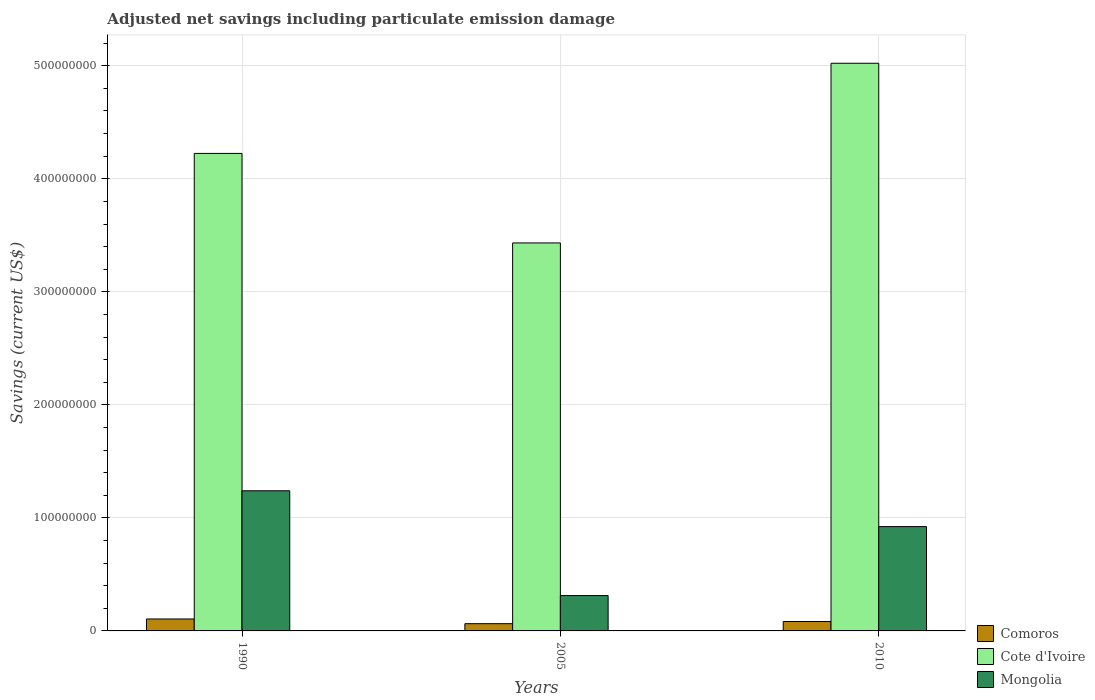How many different coloured bars are there?
Offer a very short reply. 3. How many groups of bars are there?
Offer a terse response. 3. Are the number of bars per tick equal to the number of legend labels?
Give a very brief answer. Yes. Are the number of bars on each tick of the X-axis equal?
Keep it short and to the point. Yes. How many bars are there on the 3rd tick from the left?
Offer a terse response. 3. How many bars are there on the 3rd tick from the right?
Make the answer very short. 3. What is the net savings in Cote d'Ivoire in 2005?
Offer a terse response. 3.43e+08. Across all years, what is the maximum net savings in Cote d'Ivoire?
Your response must be concise. 5.02e+08. Across all years, what is the minimum net savings in Comoros?
Offer a terse response. 6.41e+06. In which year was the net savings in Comoros minimum?
Your answer should be very brief. 2005. What is the total net savings in Mongolia in the graph?
Offer a very short reply. 2.48e+08. What is the difference between the net savings in Cote d'Ivoire in 2005 and that in 2010?
Keep it short and to the point. -1.59e+08. What is the difference between the net savings in Mongolia in 2010 and the net savings in Cote d'Ivoire in 2005?
Your answer should be compact. -2.51e+08. What is the average net savings in Comoros per year?
Offer a terse response. 8.43e+06. In the year 2010, what is the difference between the net savings in Comoros and net savings in Mongolia?
Ensure brevity in your answer.  -8.40e+07. What is the ratio of the net savings in Comoros in 2005 to that in 2010?
Offer a terse response. 0.77. Is the difference between the net savings in Comoros in 1990 and 2010 greater than the difference between the net savings in Mongolia in 1990 and 2010?
Make the answer very short. No. What is the difference between the highest and the second highest net savings in Mongolia?
Make the answer very short. 3.17e+07. What is the difference between the highest and the lowest net savings in Comoros?
Your response must be concise. 4.16e+06. What does the 1st bar from the left in 2010 represents?
Make the answer very short. Comoros. What does the 1st bar from the right in 1990 represents?
Your response must be concise. Mongolia. Is it the case that in every year, the sum of the net savings in Cote d'Ivoire and net savings in Mongolia is greater than the net savings in Comoros?
Your answer should be very brief. Yes. How many bars are there?
Your answer should be compact. 9. How many years are there in the graph?
Make the answer very short. 3. Does the graph contain any zero values?
Your answer should be compact. No. Does the graph contain grids?
Your answer should be compact. Yes. Where does the legend appear in the graph?
Offer a terse response. Bottom right. How many legend labels are there?
Make the answer very short. 3. How are the legend labels stacked?
Ensure brevity in your answer.  Vertical. What is the title of the graph?
Provide a succinct answer. Adjusted net savings including particulate emission damage. What is the label or title of the Y-axis?
Offer a terse response. Savings (current US$). What is the Savings (current US$) in Comoros in 1990?
Provide a succinct answer. 1.06e+07. What is the Savings (current US$) in Cote d'Ivoire in 1990?
Give a very brief answer. 4.22e+08. What is the Savings (current US$) in Mongolia in 1990?
Your answer should be very brief. 1.24e+08. What is the Savings (current US$) in Comoros in 2005?
Give a very brief answer. 6.41e+06. What is the Savings (current US$) of Cote d'Ivoire in 2005?
Make the answer very short. 3.43e+08. What is the Savings (current US$) of Mongolia in 2005?
Offer a terse response. 3.13e+07. What is the Savings (current US$) in Comoros in 2010?
Provide a short and direct response. 8.33e+06. What is the Savings (current US$) of Cote d'Ivoire in 2010?
Provide a short and direct response. 5.02e+08. What is the Savings (current US$) of Mongolia in 2010?
Keep it short and to the point. 9.23e+07. Across all years, what is the maximum Savings (current US$) in Comoros?
Your response must be concise. 1.06e+07. Across all years, what is the maximum Savings (current US$) in Cote d'Ivoire?
Ensure brevity in your answer.  5.02e+08. Across all years, what is the maximum Savings (current US$) of Mongolia?
Give a very brief answer. 1.24e+08. Across all years, what is the minimum Savings (current US$) in Comoros?
Your answer should be very brief. 6.41e+06. Across all years, what is the minimum Savings (current US$) in Cote d'Ivoire?
Offer a terse response. 3.43e+08. Across all years, what is the minimum Savings (current US$) in Mongolia?
Your answer should be compact. 3.13e+07. What is the total Savings (current US$) of Comoros in the graph?
Provide a short and direct response. 2.53e+07. What is the total Savings (current US$) of Cote d'Ivoire in the graph?
Your response must be concise. 1.27e+09. What is the total Savings (current US$) in Mongolia in the graph?
Give a very brief answer. 2.48e+08. What is the difference between the Savings (current US$) of Comoros in 1990 and that in 2005?
Give a very brief answer. 4.16e+06. What is the difference between the Savings (current US$) in Cote d'Ivoire in 1990 and that in 2005?
Keep it short and to the point. 7.92e+07. What is the difference between the Savings (current US$) of Mongolia in 1990 and that in 2005?
Give a very brief answer. 9.27e+07. What is the difference between the Savings (current US$) in Comoros in 1990 and that in 2010?
Your answer should be compact. 2.24e+06. What is the difference between the Savings (current US$) of Cote d'Ivoire in 1990 and that in 2010?
Offer a very short reply. -7.98e+07. What is the difference between the Savings (current US$) in Mongolia in 1990 and that in 2010?
Provide a short and direct response. 3.17e+07. What is the difference between the Savings (current US$) of Comoros in 2005 and that in 2010?
Offer a very short reply. -1.92e+06. What is the difference between the Savings (current US$) of Cote d'Ivoire in 2005 and that in 2010?
Give a very brief answer. -1.59e+08. What is the difference between the Savings (current US$) of Mongolia in 2005 and that in 2010?
Your answer should be very brief. -6.10e+07. What is the difference between the Savings (current US$) of Comoros in 1990 and the Savings (current US$) of Cote d'Ivoire in 2005?
Your response must be concise. -3.33e+08. What is the difference between the Savings (current US$) of Comoros in 1990 and the Savings (current US$) of Mongolia in 2005?
Offer a very short reply. -2.07e+07. What is the difference between the Savings (current US$) of Cote d'Ivoire in 1990 and the Savings (current US$) of Mongolia in 2005?
Your answer should be compact. 3.91e+08. What is the difference between the Savings (current US$) of Comoros in 1990 and the Savings (current US$) of Cote d'Ivoire in 2010?
Provide a succinct answer. -4.92e+08. What is the difference between the Savings (current US$) of Comoros in 1990 and the Savings (current US$) of Mongolia in 2010?
Offer a terse response. -8.17e+07. What is the difference between the Savings (current US$) in Cote d'Ivoire in 1990 and the Savings (current US$) in Mongolia in 2010?
Give a very brief answer. 3.30e+08. What is the difference between the Savings (current US$) in Comoros in 2005 and the Savings (current US$) in Cote d'Ivoire in 2010?
Offer a terse response. -4.96e+08. What is the difference between the Savings (current US$) of Comoros in 2005 and the Savings (current US$) of Mongolia in 2010?
Your response must be concise. -8.59e+07. What is the difference between the Savings (current US$) in Cote d'Ivoire in 2005 and the Savings (current US$) in Mongolia in 2010?
Give a very brief answer. 2.51e+08. What is the average Savings (current US$) in Comoros per year?
Give a very brief answer. 8.43e+06. What is the average Savings (current US$) of Cote d'Ivoire per year?
Provide a succinct answer. 4.23e+08. What is the average Savings (current US$) of Mongolia per year?
Your answer should be very brief. 8.25e+07. In the year 1990, what is the difference between the Savings (current US$) of Comoros and Savings (current US$) of Cote d'Ivoire?
Provide a succinct answer. -4.12e+08. In the year 1990, what is the difference between the Savings (current US$) in Comoros and Savings (current US$) in Mongolia?
Offer a terse response. -1.13e+08. In the year 1990, what is the difference between the Savings (current US$) of Cote d'Ivoire and Savings (current US$) of Mongolia?
Offer a terse response. 2.98e+08. In the year 2005, what is the difference between the Savings (current US$) of Comoros and Savings (current US$) of Cote d'Ivoire?
Your answer should be compact. -3.37e+08. In the year 2005, what is the difference between the Savings (current US$) in Comoros and Savings (current US$) in Mongolia?
Give a very brief answer. -2.49e+07. In the year 2005, what is the difference between the Savings (current US$) of Cote d'Ivoire and Savings (current US$) of Mongolia?
Your answer should be very brief. 3.12e+08. In the year 2010, what is the difference between the Savings (current US$) in Comoros and Savings (current US$) in Cote d'Ivoire?
Ensure brevity in your answer.  -4.94e+08. In the year 2010, what is the difference between the Savings (current US$) of Comoros and Savings (current US$) of Mongolia?
Give a very brief answer. -8.40e+07. In the year 2010, what is the difference between the Savings (current US$) of Cote d'Ivoire and Savings (current US$) of Mongolia?
Keep it short and to the point. 4.10e+08. What is the ratio of the Savings (current US$) in Comoros in 1990 to that in 2005?
Offer a terse response. 1.65. What is the ratio of the Savings (current US$) in Cote d'Ivoire in 1990 to that in 2005?
Provide a succinct answer. 1.23. What is the ratio of the Savings (current US$) in Mongolia in 1990 to that in 2005?
Make the answer very short. 3.96. What is the ratio of the Savings (current US$) in Comoros in 1990 to that in 2010?
Give a very brief answer. 1.27. What is the ratio of the Savings (current US$) in Cote d'Ivoire in 1990 to that in 2010?
Offer a very short reply. 0.84. What is the ratio of the Savings (current US$) in Mongolia in 1990 to that in 2010?
Keep it short and to the point. 1.34. What is the ratio of the Savings (current US$) in Comoros in 2005 to that in 2010?
Your response must be concise. 0.77. What is the ratio of the Savings (current US$) in Cote d'Ivoire in 2005 to that in 2010?
Offer a very short reply. 0.68. What is the ratio of the Savings (current US$) of Mongolia in 2005 to that in 2010?
Provide a succinct answer. 0.34. What is the difference between the highest and the second highest Savings (current US$) of Comoros?
Provide a short and direct response. 2.24e+06. What is the difference between the highest and the second highest Savings (current US$) of Cote d'Ivoire?
Ensure brevity in your answer.  7.98e+07. What is the difference between the highest and the second highest Savings (current US$) in Mongolia?
Offer a terse response. 3.17e+07. What is the difference between the highest and the lowest Savings (current US$) in Comoros?
Offer a terse response. 4.16e+06. What is the difference between the highest and the lowest Savings (current US$) of Cote d'Ivoire?
Ensure brevity in your answer.  1.59e+08. What is the difference between the highest and the lowest Savings (current US$) of Mongolia?
Make the answer very short. 9.27e+07. 